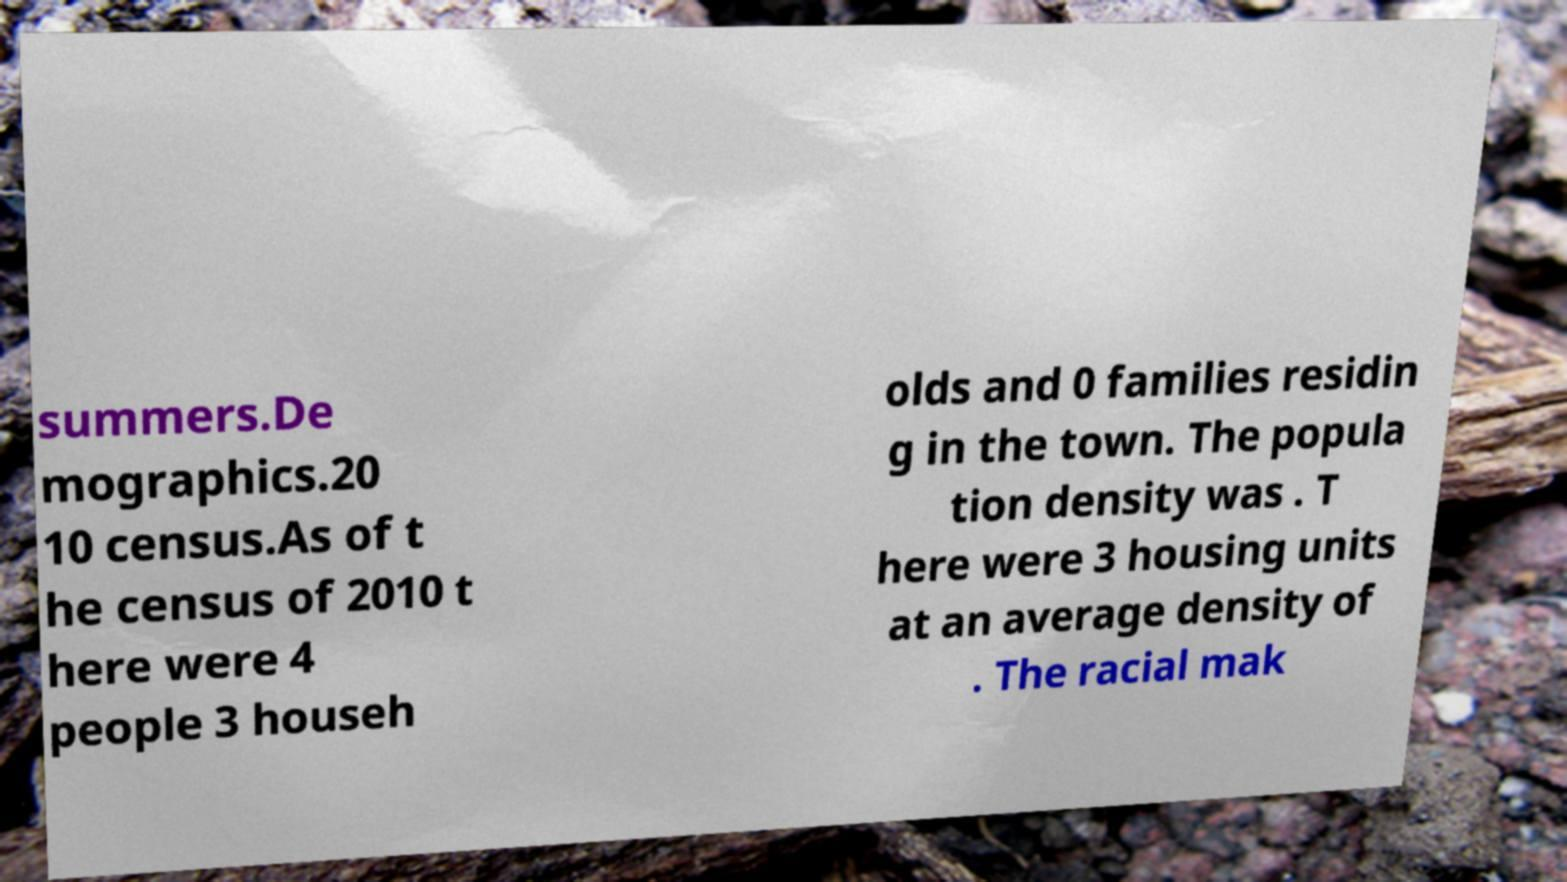Please read and relay the text visible in this image. What does it say? summers.De mographics.20 10 census.As of t he census of 2010 t here were 4 people 3 househ olds and 0 families residin g in the town. The popula tion density was . T here were 3 housing units at an average density of . The racial mak 